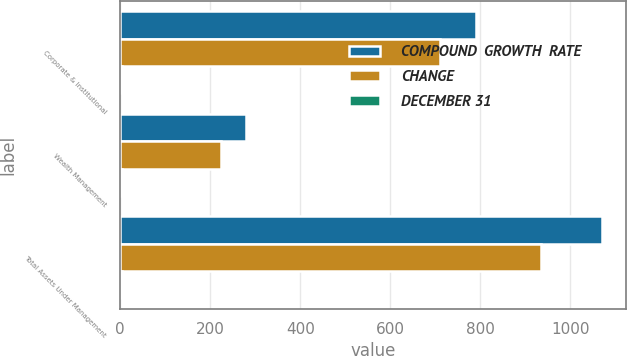<chart> <loc_0><loc_0><loc_500><loc_500><stacked_bar_chart><ecel><fcel>Corporate & Institutional<fcel>Wealth Management<fcel>Total Assets Under Management<nl><fcel>COMPOUND  GROWTH  RATE<fcel>790.8<fcel>278.6<fcel>1069.4<nl><fcel>CHANGE<fcel>709.6<fcel>224.5<fcel>934.1<nl><fcel>DECEMBER 31<fcel>4<fcel>5<fcel>4<nl></chart> 